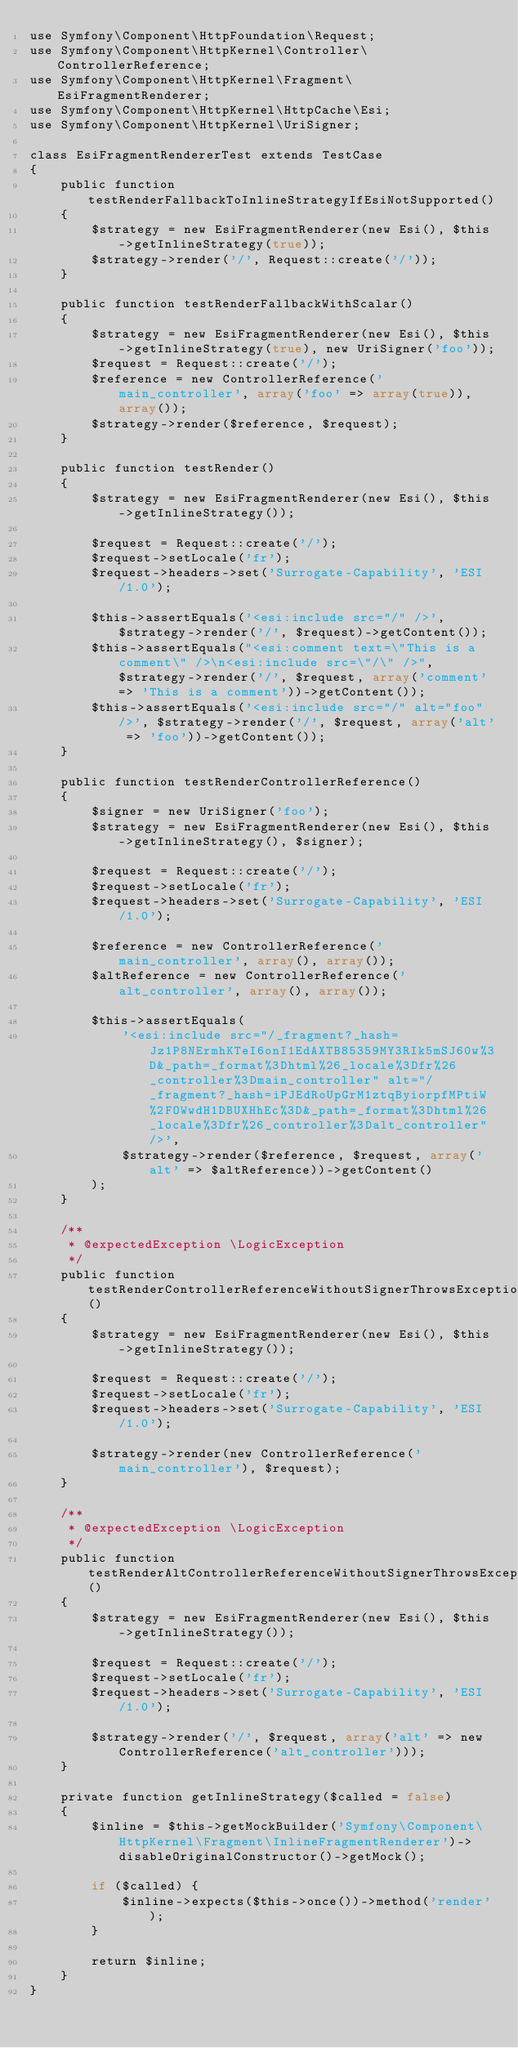<code> <loc_0><loc_0><loc_500><loc_500><_PHP_>use Symfony\Component\HttpFoundation\Request;
use Symfony\Component\HttpKernel\Controller\ControllerReference;
use Symfony\Component\HttpKernel\Fragment\EsiFragmentRenderer;
use Symfony\Component\HttpKernel\HttpCache\Esi;
use Symfony\Component\HttpKernel\UriSigner;

class EsiFragmentRendererTest extends TestCase
{
    public function testRenderFallbackToInlineStrategyIfEsiNotSupported()
    {
        $strategy = new EsiFragmentRenderer(new Esi(), $this->getInlineStrategy(true));
        $strategy->render('/', Request::create('/'));
    }

    public function testRenderFallbackWithScalar()
    {
        $strategy = new EsiFragmentRenderer(new Esi(), $this->getInlineStrategy(true), new UriSigner('foo'));
        $request = Request::create('/');
        $reference = new ControllerReference('main_controller', array('foo' => array(true)), array());
        $strategy->render($reference, $request);
    }

    public function testRender()
    {
        $strategy = new EsiFragmentRenderer(new Esi(), $this->getInlineStrategy());

        $request = Request::create('/');
        $request->setLocale('fr');
        $request->headers->set('Surrogate-Capability', 'ESI/1.0');

        $this->assertEquals('<esi:include src="/" />', $strategy->render('/', $request)->getContent());
        $this->assertEquals("<esi:comment text=\"This is a comment\" />\n<esi:include src=\"/\" />", $strategy->render('/', $request, array('comment' => 'This is a comment'))->getContent());
        $this->assertEquals('<esi:include src="/" alt="foo" />', $strategy->render('/', $request, array('alt' => 'foo'))->getContent());
    }

    public function testRenderControllerReference()
    {
        $signer = new UriSigner('foo');
        $strategy = new EsiFragmentRenderer(new Esi(), $this->getInlineStrategy(), $signer);

        $request = Request::create('/');
        $request->setLocale('fr');
        $request->headers->set('Surrogate-Capability', 'ESI/1.0');

        $reference = new ControllerReference('main_controller', array(), array());
        $altReference = new ControllerReference('alt_controller', array(), array());

        $this->assertEquals(
            '<esi:include src="/_fragment?_hash=Jz1P8NErmhKTeI6onI1EdAXTB85359MY3RIk5mSJ60w%3D&_path=_format%3Dhtml%26_locale%3Dfr%26_controller%3Dmain_controller" alt="/_fragment?_hash=iPJEdRoUpGrM1ztqByiorpfMPtiW%2FOWwdH1DBUXHhEc%3D&_path=_format%3Dhtml%26_locale%3Dfr%26_controller%3Dalt_controller" />',
            $strategy->render($reference, $request, array('alt' => $altReference))->getContent()
        );
    }

    /**
     * @expectedException \LogicException
     */
    public function testRenderControllerReferenceWithoutSignerThrowsException()
    {
        $strategy = new EsiFragmentRenderer(new Esi(), $this->getInlineStrategy());

        $request = Request::create('/');
        $request->setLocale('fr');
        $request->headers->set('Surrogate-Capability', 'ESI/1.0');

        $strategy->render(new ControllerReference('main_controller'), $request);
    }

    /**
     * @expectedException \LogicException
     */
    public function testRenderAltControllerReferenceWithoutSignerThrowsException()
    {
        $strategy = new EsiFragmentRenderer(new Esi(), $this->getInlineStrategy());

        $request = Request::create('/');
        $request->setLocale('fr');
        $request->headers->set('Surrogate-Capability', 'ESI/1.0');

        $strategy->render('/', $request, array('alt' => new ControllerReference('alt_controller')));
    }

    private function getInlineStrategy($called = false)
    {
        $inline = $this->getMockBuilder('Symfony\Component\HttpKernel\Fragment\InlineFragmentRenderer')->disableOriginalConstructor()->getMock();

        if ($called) {
            $inline->expects($this->once())->method('render');
        }

        return $inline;
    }
}
</code> 